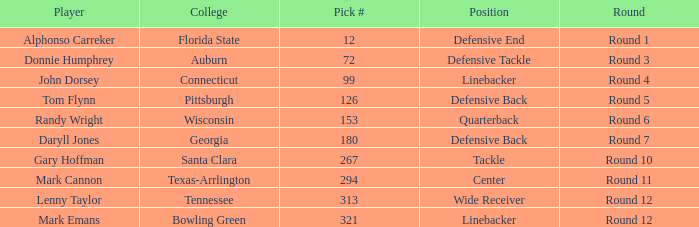What is the Position of Pick #321? Linebacker. 